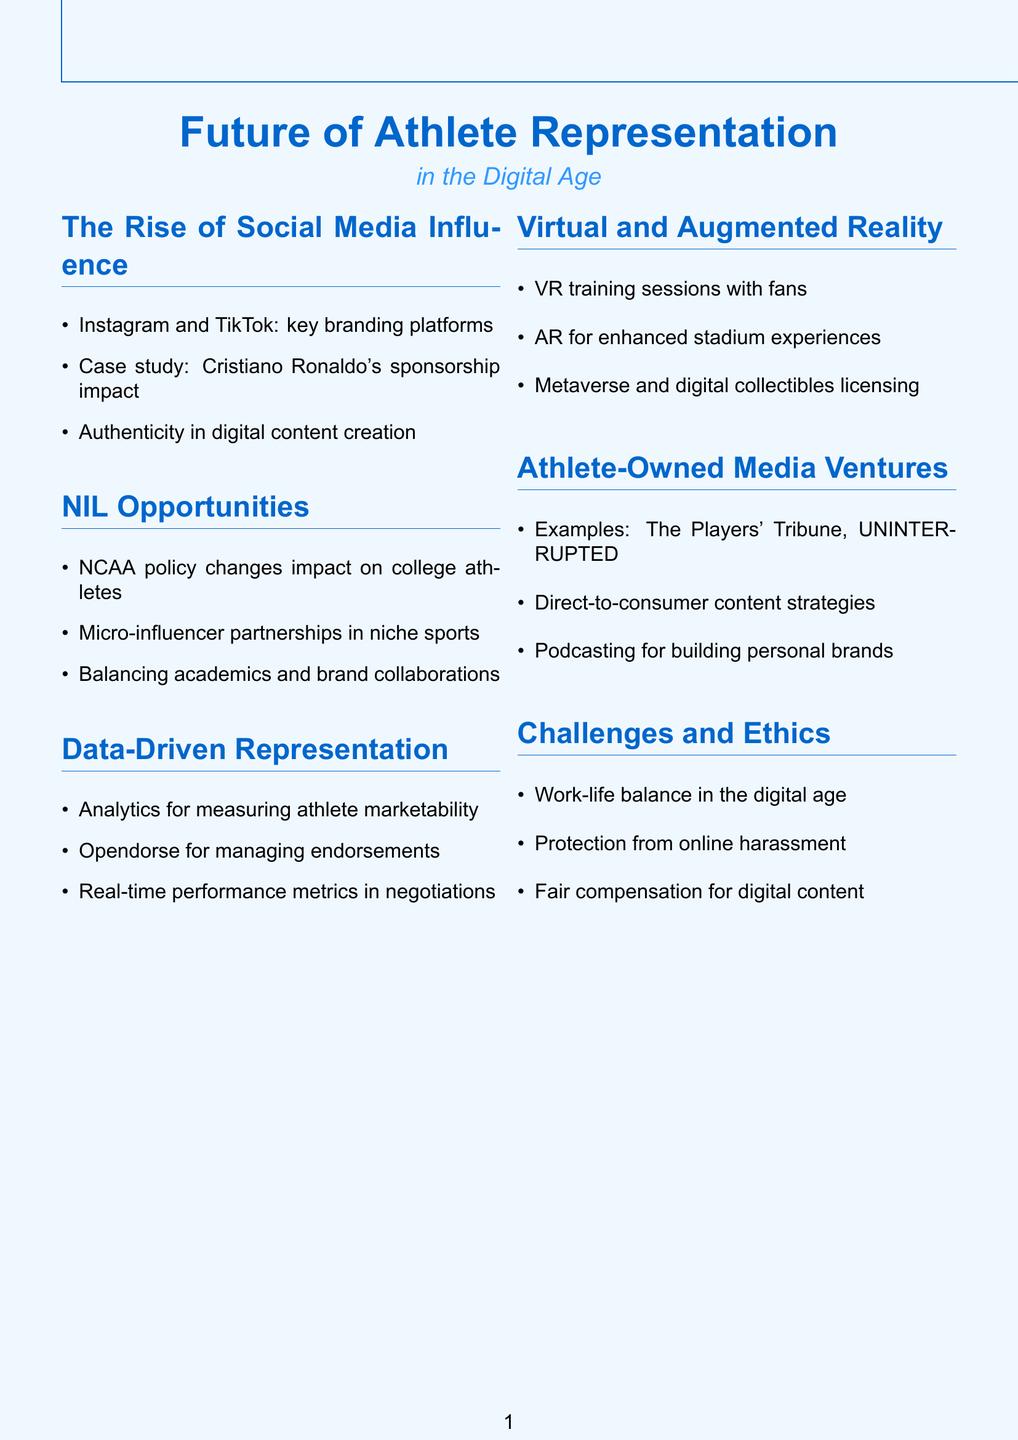What are key platforms for athlete branding? The document lists Instagram and TikTok as key platforms for athlete branding.
Answer: Instagram and TikTok What is a notable case study mentioned in the document? The case study highlighted is about Cristiano Ronaldo's social media impact on sponsorship deals.
Answer: Cristiano Ronaldo What are NCAA policy changes impacting? The NCAA policy changes are impacting college athletes regarding their name, image, and likeness opportunities.
Answer: College athletes What platform is mentioned for managing endorsement opportunities? The document refers to Opendorse as a platform for managing endorsement opportunities.
Answer: Opendorse What is the potential use of VR sessions mentioned? The potential use of VR is for training sessions with fans.
Answer: Training sessions with fans What are two examples of athlete-owned media ventures? Two examples mentioned in the document are The Players' Tribune and UNINTERRUPTED.
Answer: The Players' Tribune, UNINTERRUPTED What ethical challenge is highlighted regarding athletes in digital media? The document mentions protecting athletes from online harassment as an ethical challenge.
Answer: Online harassment What is one way data is used in athlete representation? The document states that analytics are utilized to measure athlete marketability.
Answer: Measure athlete marketability What type of content strategy is discussed for athletes? The document discusses direct-to-consumer content strategies for athletes.
Answer: Direct-to-consumer content strategies 